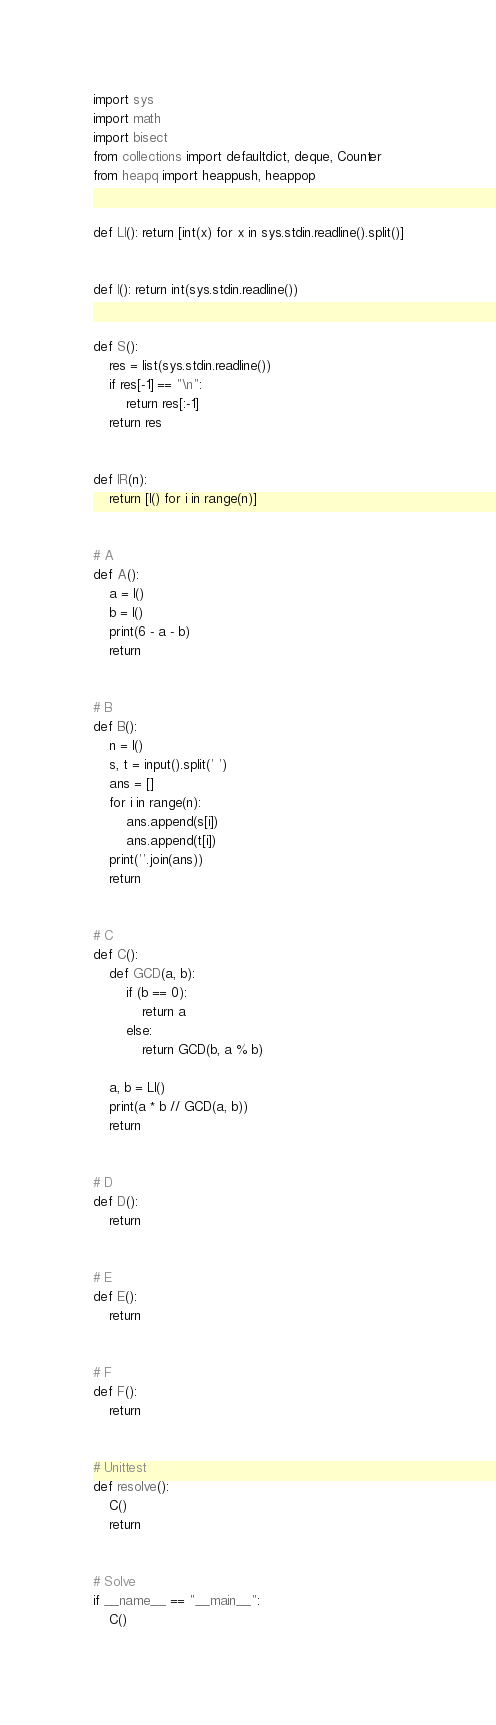Convert code to text. <code><loc_0><loc_0><loc_500><loc_500><_Python_>import sys
import math
import bisect
from collections import defaultdict, deque, Counter
from heapq import heappush, heappop


def LI(): return [int(x) for x in sys.stdin.readline().split()]


def I(): return int(sys.stdin.readline())


def S():
    res = list(sys.stdin.readline())
    if res[-1] == "\n":
        return res[:-1]
    return res


def IR(n):
    return [I() for i in range(n)]


# A
def A():
    a = I()
    b = I()
    print(6 - a - b)
    return


# B
def B():
    n = I()
    s, t = input().split(' ')
    ans = []
    for i in range(n):
        ans.append(s[i])
        ans.append(t[i])
    print(''.join(ans))
    return


# C
def C():
    def GCD(a, b):
        if (b == 0):
            return a
        else:
            return GCD(b, a % b)

    a, b = LI()
    print(a * b // GCD(a, b))
    return


# D
def D():
    return


# E
def E():
    return


# F
def F():
    return


# Unittest
def resolve():
    C()
    return


# Solve
if __name__ == "__main__":
    C()
</code> 